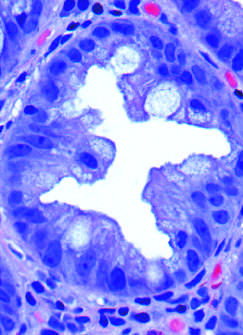does movat produce a serrated architecture when glands are cut in cross-section?
Answer the question using a single word or phrase. No 